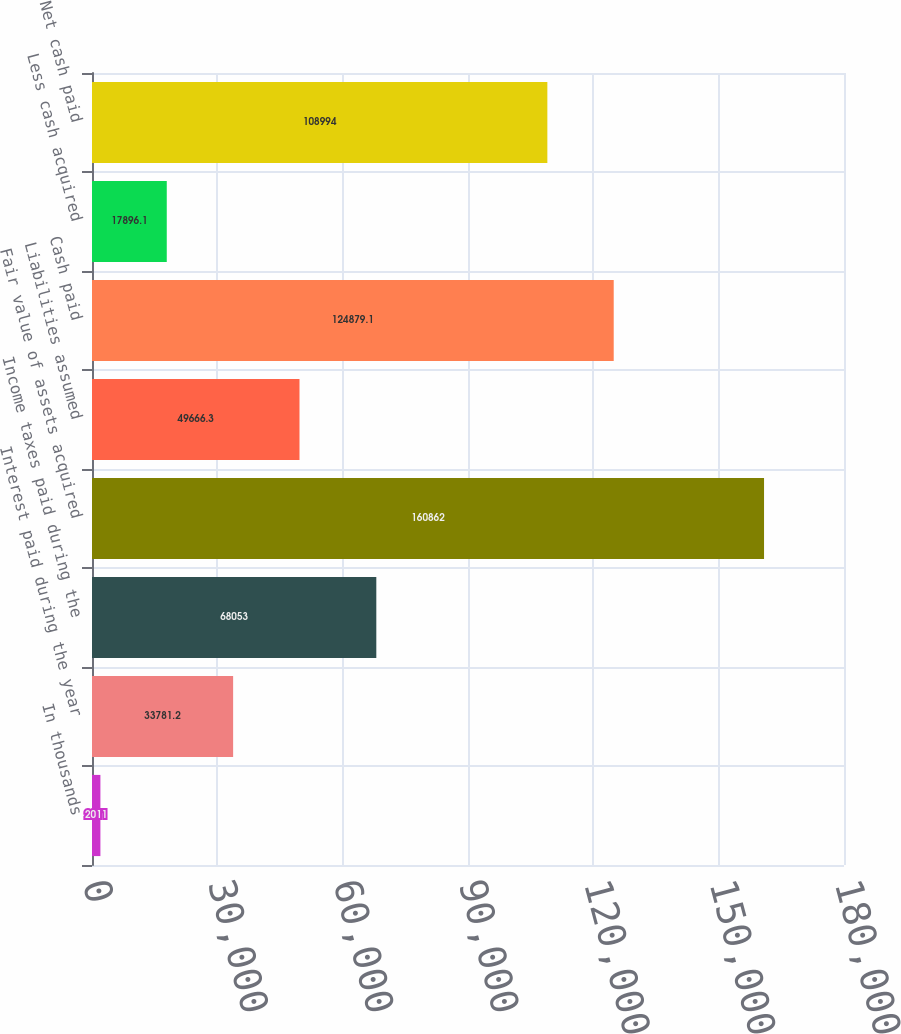Convert chart. <chart><loc_0><loc_0><loc_500><loc_500><bar_chart><fcel>In thousands<fcel>Interest paid during the year<fcel>Income taxes paid during the<fcel>Fair value of assets acquired<fcel>Liabilities assumed<fcel>Cash paid<fcel>Less cash acquired<fcel>Net cash paid<nl><fcel>2011<fcel>33781.2<fcel>68053<fcel>160862<fcel>49666.3<fcel>124879<fcel>17896.1<fcel>108994<nl></chart> 